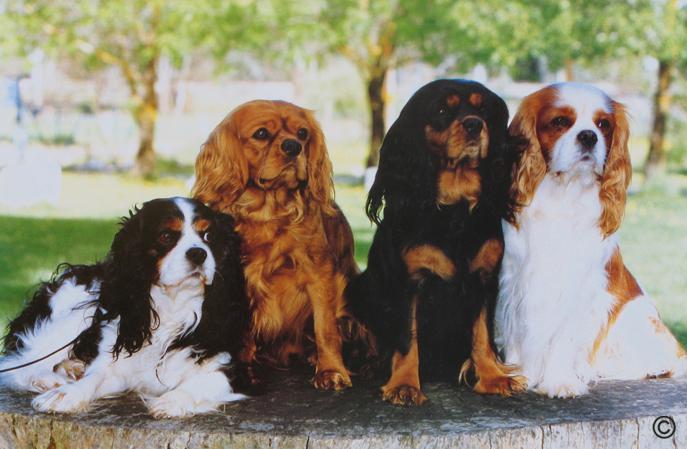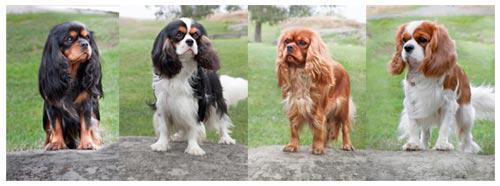The first image is the image on the left, the second image is the image on the right. For the images shown, is this caption "Each image is a full body shot of four different dogs." true? Answer yes or no. Yes. 